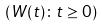<formula> <loc_0><loc_0><loc_500><loc_500>( W ( t ) \colon t \geq 0 )</formula> 